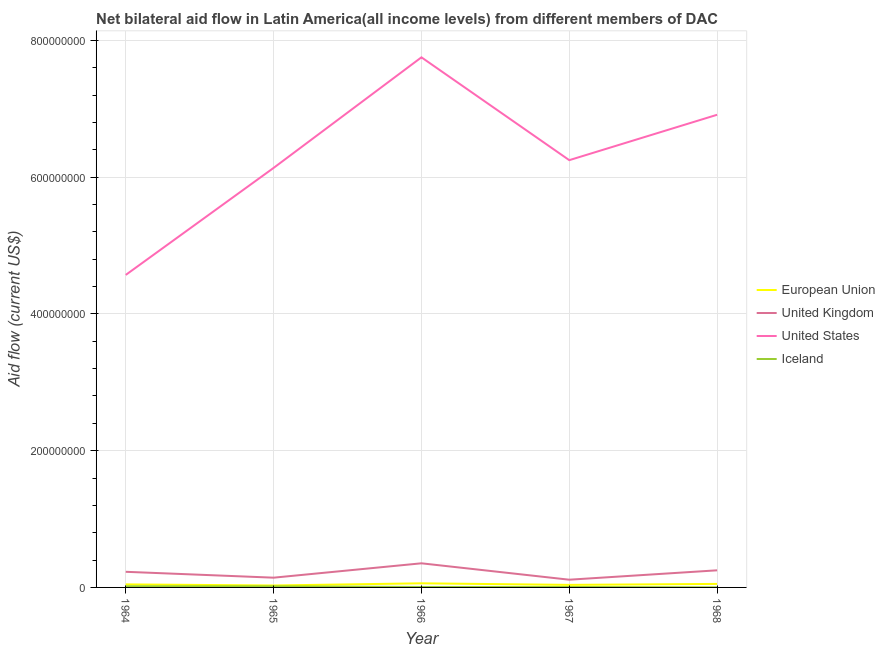How many different coloured lines are there?
Your response must be concise. 4. Is the number of lines equal to the number of legend labels?
Make the answer very short. Yes. What is the amount of aid given by us in 1968?
Offer a terse response. 6.91e+08. Across all years, what is the maximum amount of aid given by iceland?
Provide a short and direct response. 1.67e+06. Across all years, what is the minimum amount of aid given by iceland?
Make the answer very short. 1.50e+05. In which year was the amount of aid given by eu maximum?
Provide a short and direct response. 1966. In which year was the amount of aid given by iceland minimum?
Your answer should be very brief. 1968. What is the total amount of aid given by iceland in the graph?
Make the answer very short. 4.69e+06. What is the difference between the amount of aid given by uk in 1964 and that in 1966?
Keep it short and to the point. -1.24e+07. What is the difference between the amount of aid given by us in 1966 and the amount of aid given by eu in 1968?
Your answer should be very brief. 7.70e+08. What is the average amount of aid given by iceland per year?
Make the answer very short. 9.38e+05. In the year 1965, what is the difference between the amount of aid given by us and amount of aid given by eu?
Provide a short and direct response. 6.11e+08. What is the ratio of the amount of aid given by eu in 1966 to that in 1968?
Provide a short and direct response. 1.17. What is the difference between the highest and the second highest amount of aid given by eu?
Keep it short and to the point. 8.60e+05. What is the difference between the highest and the lowest amount of aid given by us?
Give a very brief answer. 3.18e+08. Is the sum of the amount of aid given by us in 1964 and 1967 greater than the maximum amount of aid given by eu across all years?
Your answer should be very brief. Yes. Is it the case that in every year, the sum of the amount of aid given by eu and amount of aid given by iceland is greater than the sum of amount of aid given by uk and amount of aid given by us?
Make the answer very short. No. Is it the case that in every year, the sum of the amount of aid given by eu and amount of aid given by uk is greater than the amount of aid given by us?
Ensure brevity in your answer.  No. Is the amount of aid given by eu strictly greater than the amount of aid given by iceland over the years?
Offer a very short reply. Yes. Is the amount of aid given by uk strictly less than the amount of aid given by us over the years?
Your answer should be compact. Yes. How many years are there in the graph?
Keep it short and to the point. 5. What is the difference between two consecutive major ticks on the Y-axis?
Provide a short and direct response. 2.00e+08. Are the values on the major ticks of Y-axis written in scientific E-notation?
Your answer should be very brief. No. Does the graph contain any zero values?
Offer a very short reply. No. How many legend labels are there?
Keep it short and to the point. 4. How are the legend labels stacked?
Provide a short and direct response. Vertical. What is the title of the graph?
Make the answer very short. Net bilateral aid flow in Latin America(all income levels) from different members of DAC. What is the label or title of the Y-axis?
Your answer should be compact. Aid flow (current US$). What is the Aid flow (current US$) of European Union in 1964?
Your response must be concise. 4.45e+06. What is the Aid flow (current US$) in United Kingdom in 1964?
Keep it short and to the point. 2.29e+07. What is the Aid flow (current US$) of United States in 1964?
Make the answer very short. 4.57e+08. What is the Aid flow (current US$) in Iceland in 1964?
Make the answer very short. 1.67e+06. What is the Aid flow (current US$) of European Union in 1965?
Make the answer very short. 2.85e+06. What is the Aid flow (current US$) in United Kingdom in 1965?
Your answer should be compact. 1.43e+07. What is the Aid flow (current US$) in United States in 1965?
Your answer should be compact. 6.13e+08. What is the Aid flow (current US$) of Iceland in 1965?
Keep it short and to the point. 1.53e+06. What is the Aid flow (current US$) in European Union in 1966?
Provide a short and direct response. 6.01e+06. What is the Aid flow (current US$) of United Kingdom in 1966?
Offer a terse response. 3.53e+07. What is the Aid flow (current US$) in United States in 1966?
Your answer should be very brief. 7.75e+08. What is the Aid flow (current US$) in Iceland in 1966?
Give a very brief answer. 6.80e+05. What is the Aid flow (current US$) of European Union in 1967?
Give a very brief answer. 3.73e+06. What is the Aid flow (current US$) in United Kingdom in 1967?
Keep it short and to the point. 1.13e+07. What is the Aid flow (current US$) of United States in 1967?
Your answer should be very brief. 6.25e+08. What is the Aid flow (current US$) in European Union in 1968?
Provide a succinct answer. 5.15e+06. What is the Aid flow (current US$) of United Kingdom in 1968?
Provide a short and direct response. 2.50e+07. What is the Aid flow (current US$) of United States in 1968?
Offer a very short reply. 6.91e+08. Across all years, what is the maximum Aid flow (current US$) of European Union?
Ensure brevity in your answer.  6.01e+06. Across all years, what is the maximum Aid flow (current US$) in United Kingdom?
Offer a terse response. 3.53e+07. Across all years, what is the maximum Aid flow (current US$) in United States?
Your response must be concise. 7.75e+08. Across all years, what is the maximum Aid flow (current US$) of Iceland?
Your response must be concise. 1.67e+06. Across all years, what is the minimum Aid flow (current US$) in European Union?
Provide a succinct answer. 2.85e+06. Across all years, what is the minimum Aid flow (current US$) of United Kingdom?
Your answer should be compact. 1.13e+07. Across all years, what is the minimum Aid flow (current US$) of United States?
Your answer should be compact. 4.57e+08. What is the total Aid flow (current US$) of European Union in the graph?
Give a very brief answer. 2.22e+07. What is the total Aid flow (current US$) of United Kingdom in the graph?
Your answer should be very brief. 1.09e+08. What is the total Aid flow (current US$) of United States in the graph?
Your response must be concise. 3.16e+09. What is the total Aid flow (current US$) in Iceland in the graph?
Your answer should be compact. 4.69e+06. What is the difference between the Aid flow (current US$) of European Union in 1964 and that in 1965?
Your response must be concise. 1.60e+06. What is the difference between the Aid flow (current US$) in United Kingdom in 1964 and that in 1965?
Your response must be concise. 8.60e+06. What is the difference between the Aid flow (current US$) in United States in 1964 and that in 1965?
Provide a succinct answer. -1.56e+08. What is the difference between the Aid flow (current US$) of Iceland in 1964 and that in 1965?
Offer a very short reply. 1.40e+05. What is the difference between the Aid flow (current US$) of European Union in 1964 and that in 1966?
Provide a succinct answer. -1.56e+06. What is the difference between the Aid flow (current US$) of United Kingdom in 1964 and that in 1966?
Keep it short and to the point. -1.24e+07. What is the difference between the Aid flow (current US$) in United States in 1964 and that in 1966?
Make the answer very short. -3.18e+08. What is the difference between the Aid flow (current US$) in Iceland in 1964 and that in 1966?
Keep it short and to the point. 9.90e+05. What is the difference between the Aid flow (current US$) of European Union in 1964 and that in 1967?
Give a very brief answer. 7.20e+05. What is the difference between the Aid flow (current US$) of United Kingdom in 1964 and that in 1967?
Your response must be concise. 1.16e+07. What is the difference between the Aid flow (current US$) of United States in 1964 and that in 1967?
Your answer should be very brief. -1.68e+08. What is the difference between the Aid flow (current US$) in Iceland in 1964 and that in 1967?
Offer a terse response. 1.01e+06. What is the difference between the Aid flow (current US$) of European Union in 1964 and that in 1968?
Keep it short and to the point. -7.00e+05. What is the difference between the Aid flow (current US$) in United Kingdom in 1964 and that in 1968?
Provide a succinct answer. -2.17e+06. What is the difference between the Aid flow (current US$) in United States in 1964 and that in 1968?
Offer a terse response. -2.34e+08. What is the difference between the Aid flow (current US$) of Iceland in 1964 and that in 1968?
Ensure brevity in your answer.  1.52e+06. What is the difference between the Aid flow (current US$) in European Union in 1965 and that in 1966?
Your answer should be compact. -3.16e+06. What is the difference between the Aid flow (current US$) of United Kingdom in 1965 and that in 1966?
Provide a succinct answer. -2.10e+07. What is the difference between the Aid flow (current US$) of United States in 1965 and that in 1966?
Your answer should be very brief. -1.62e+08. What is the difference between the Aid flow (current US$) of Iceland in 1965 and that in 1966?
Provide a short and direct response. 8.50e+05. What is the difference between the Aid flow (current US$) of European Union in 1965 and that in 1967?
Offer a terse response. -8.80e+05. What is the difference between the Aid flow (current US$) of United Kingdom in 1965 and that in 1967?
Your answer should be compact. 2.97e+06. What is the difference between the Aid flow (current US$) in United States in 1965 and that in 1967?
Offer a terse response. -1.14e+07. What is the difference between the Aid flow (current US$) in Iceland in 1965 and that in 1967?
Ensure brevity in your answer.  8.70e+05. What is the difference between the Aid flow (current US$) of European Union in 1965 and that in 1968?
Your answer should be very brief. -2.30e+06. What is the difference between the Aid flow (current US$) in United Kingdom in 1965 and that in 1968?
Offer a terse response. -1.08e+07. What is the difference between the Aid flow (current US$) in United States in 1965 and that in 1968?
Keep it short and to the point. -7.77e+07. What is the difference between the Aid flow (current US$) of Iceland in 1965 and that in 1968?
Make the answer very short. 1.38e+06. What is the difference between the Aid flow (current US$) of European Union in 1966 and that in 1967?
Keep it short and to the point. 2.28e+06. What is the difference between the Aid flow (current US$) of United Kingdom in 1966 and that in 1967?
Give a very brief answer. 2.40e+07. What is the difference between the Aid flow (current US$) in United States in 1966 and that in 1967?
Provide a succinct answer. 1.50e+08. What is the difference between the Aid flow (current US$) in Iceland in 1966 and that in 1967?
Your answer should be very brief. 2.00e+04. What is the difference between the Aid flow (current US$) of European Union in 1966 and that in 1968?
Provide a short and direct response. 8.60e+05. What is the difference between the Aid flow (current US$) in United Kingdom in 1966 and that in 1968?
Ensure brevity in your answer.  1.02e+07. What is the difference between the Aid flow (current US$) in United States in 1966 and that in 1968?
Provide a short and direct response. 8.40e+07. What is the difference between the Aid flow (current US$) of Iceland in 1966 and that in 1968?
Your answer should be very brief. 5.30e+05. What is the difference between the Aid flow (current US$) in European Union in 1967 and that in 1968?
Your response must be concise. -1.42e+06. What is the difference between the Aid flow (current US$) in United Kingdom in 1967 and that in 1968?
Your answer should be compact. -1.37e+07. What is the difference between the Aid flow (current US$) in United States in 1967 and that in 1968?
Offer a terse response. -6.64e+07. What is the difference between the Aid flow (current US$) of Iceland in 1967 and that in 1968?
Provide a short and direct response. 5.10e+05. What is the difference between the Aid flow (current US$) of European Union in 1964 and the Aid flow (current US$) of United Kingdom in 1965?
Keep it short and to the point. -9.81e+06. What is the difference between the Aid flow (current US$) in European Union in 1964 and the Aid flow (current US$) in United States in 1965?
Your answer should be compact. -6.09e+08. What is the difference between the Aid flow (current US$) of European Union in 1964 and the Aid flow (current US$) of Iceland in 1965?
Your answer should be very brief. 2.92e+06. What is the difference between the Aid flow (current US$) in United Kingdom in 1964 and the Aid flow (current US$) in United States in 1965?
Keep it short and to the point. -5.91e+08. What is the difference between the Aid flow (current US$) of United Kingdom in 1964 and the Aid flow (current US$) of Iceland in 1965?
Give a very brief answer. 2.13e+07. What is the difference between the Aid flow (current US$) in United States in 1964 and the Aid flow (current US$) in Iceland in 1965?
Provide a short and direct response. 4.55e+08. What is the difference between the Aid flow (current US$) of European Union in 1964 and the Aid flow (current US$) of United Kingdom in 1966?
Keep it short and to the point. -3.08e+07. What is the difference between the Aid flow (current US$) of European Union in 1964 and the Aid flow (current US$) of United States in 1966?
Provide a short and direct response. -7.71e+08. What is the difference between the Aid flow (current US$) of European Union in 1964 and the Aid flow (current US$) of Iceland in 1966?
Give a very brief answer. 3.77e+06. What is the difference between the Aid flow (current US$) in United Kingdom in 1964 and the Aid flow (current US$) in United States in 1966?
Keep it short and to the point. -7.52e+08. What is the difference between the Aid flow (current US$) in United Kingdom in 1964 and the Aid flow (current US$) in Iceland in 1966?
Your answer should be very brief. 2.22e+07. What is the difference between the Aid flow (current US$) of United States in 1964 and the Aid flow (current US$) of Iceland in 1966?
Provide a short and direct response. 4.56e+08. What is the difference between the Aid flow (current US$) in European Union in 1964 and the Aid flow (current US$) in United Kingdom in 1967?
Keep it short and to the point. -6.84e+06. What is the difference between the Aid flow (current US$) in European Union in 1964 and the Aid flow (current US$) in United States in 1967?
Provide a succinct answer. -6.20e+08. What is the difference between the Aid flow (current US$) in European Union in 1964 and the Aid flow (current US$) in Iceland in 1967?
Keep it short and to the point. 3.79e+06. What is the difference between the Aid flow (current US$) in United Kingdom in 1964 and the Aid flow (current US$) in United States in 1967?
Offer a very short reply. -6.02e+08. What is the difference between the Aid flow (current US$) of United Kingdom in 1964 and the Aid flow (current US$) of Iceland in 1967?
Your response must be concise. 2.22e+07. What is the difference between the Aid flow (current US$) in United States in 1964 and the Aid flow (current US$) in Iceland in 1967?
Provide a succinct answer. 4.56e+08. What is the difference between the Aid flow (current US$) in European Union in 1964 and the Aid flow (current US$) in United Kingdom in 1968?
Ensure brevity in your answer.  -2.06e+07. What is the difference between the Aid flow (current US$) in European Union in 1964 and the Aid flow (current US$) in United States in 1968?
Your answer should be compact. -6.87e+08. What is the difference between the Aid flow (current US$) of European Union in 1964 and the Aid flow (current US$) of Iceland in 1968?
Give a very brief answer. 4.30e+06. What is the difference between the Aid flow (current US$) of United Kingdom in 1964 and the Aid flow (current US$) of United States in 1968?
Offer a terse response. -6.68e+08. What is the difference between the Aid flow (current US$) of United Kingdom in 1964 and the Aid flow (current US$) of Iceland in 1968?
Ensure brevity in your answer.  2.27e+07. What is the difference between the Aid flow (current US$) in United States in 1964 and the Aid flow (current US$) in Iceland in 1968?
Your answer should be compact. 4.57e+08. What is the difference between the Aid flow (current US$) of European Union in 1965 and the Aid flow (current US$) of United Kingdom in 1966?
Keep it short and to the point. -3.24e+07. What is the difference between the Aid flow (current US$) of European Union in 1965 and the Aid flow (current US$) of United States in 1966?
Offer a very short reply. -7.72e+08. What is the difference between the Aid flow (current US$) in European Union in 1965 and the Aid flow (current US$) in Iceland in 1966?
Provide a succinct answer. 2.17e+06. What is the difference between the Aid flow (current US$) in United Kingdom in 1965 and the Aid flow (current US$) in United States in 1966?
Provide a short and direct response. -7.61e+08. What is the difference between the Aid flow (current US$) of United Kingdom in 1965 and the Aid flow (current US$) of Iceland in 1966?
Give a very brief answer. 1.36e+07. What is the difference between the Aid flow (current US$) of United States in 1965 and the Aid flow (current US$) of Iceland in 1966?
Your answer should be compact. 6.13e+08. What is the difference between the Aid flow (current US$) of European Union in 1965 and the Aid flow (current US$) of United Kingdom in 1967?
Make the answer very short. -8.44e+06. What is the difference between the Aid flow (current US$) in European Union in 1965 and the Aid flow (current US$) in United States in 1967?
Your response must be concise. -6.22e+08. What is the difference between the Aid flow (current US$) in European Union in 1965 and the Aid flow (current US$) in Iceland in 1967?
Your answer should be very brief. 2.19e+06. What is the difference between the Aid flow (current US$) in United Kingdom in 1965 and the Aid flow (current US$) in United States in 1967?
Provide a short and direct response. -6.11e+08. What is the difference between the Aid flow (current US$) of United Kingdom in 1965 and the Aid flow (current US$) of Iceland in 1967?
Your response must be concise. 1.36e+07. What is the difference between the Aid flow (current US$) of United States in 1965 and the Aid flow (current US$) of Iceland in 1967?
Your answer should be very brief. 6.13e+08. What is the difference between the Aid flow (current US$) in European Union in 1965 and the Aid flow (current US$) in United Kingdom in 1968?
Keep it short and to the point. -2.22e+07. What is the difference between the Aid flow (current US$) in European Union in 1965 and the Aid flow (current US$) in United States in 1968?
Offer a terse response. -6.88e+08. What is the difference between the Aid flow (current US$) in European Union in 1965 and the Aid flow (current US$) in Iceland in 1968?
Your answer should be very brief. 2.70e+06. What is the difference between the Aid flow (current US$) in United Kingdom in 1965 and the Aid flow (current US$) in United States in 1968?
Your answer should be very brief. -6.77e+08. What is the difference between the Aid flow (current US$) of United Kingdom in 1965 and the Aid flow (current US$) of Iceland in 1968?
Make the answer very short. 1.41e+07. What is the difference between the Aid flow (current US$) of United States in 1965 and the Aid flow (current US$) of Iceland in 1968?
Your answer should be very brief. 6.13e+08. What is the difference between the Aid flow (current US$) in European Union in 1966 and the Aid flow (current US$) in United Kingdom in 1967?
Your answer should be compact. -5.28e+06. What is the difference between the Aid flow (current US$) in European Union in 1966 and the Aid flow (current US$) in United States in 1967?
Keep it short and to the point. -6.19e+08. What is the difference between the Aid flow (current US$) in European Union in 1966 and the Aid flow (current US$) in Iceland in 1967?
Provide a short and direct response. 5.35e+06. What is the difference between the Aid flow (current US$) of United Kingdom in 1966 and the Aid flow (current US$) of United States in 1967?
Offer a terse response. -5.90e+08. What is the difference between the Aid flow (current US$) of United Kingdom in 1966 and the Aid flow (current US$) of Iceland in 1967?
Make the answer very short. 3.46e+07. What is the difference between the Aid flow (current US$) in United States in 1966 and the Aid flow (current US$) in Iceland in 1967?
Keep it short and to the point. 7.75e+08. What is the difference between the Aid flow (current US$) in European Union in 1966 and the Aid flow (current US$) in United Kingdom in 1968?
Offer a very short reply. -1.90e+07. What is the difference between the Aid flow (current US$) of European Union in 1966 and the Aid flow (current US$) of United States in 1968?
Your response must be concise. -6.85e+08. What is the difference between the Aid flow (current US$) in European Union in 1966 and the Aid flow (current US$) in Iceland in 1968?
Your response must be concise. 5.86e+06. What is the difference between the Aid flow (current US$) of United Kingdom in 1966 and the Aid flow (current US$) of United States in 1968?
Offer a very short reply. -6.56e+08. What is the difference between the Aid flow (current US$) in United Kingdom in 1966 and the Aid flow (current US$) in Iceland in 1968?
Make the answer very short. 3.51e+07. What is the difference between the Aid flow (current US$) of United States in 1966 and the Aid flow (current US$) of Iceland in 1968?
Give a very brief answer. 7.75e+08. What is the difference between the Aid flow (current US$) of European Union in 1967 and the Aid flow (current US$) of United Kingdom in 1968?
Ensure brevity in your answer.  -2.13e+07. What is the difference between the Aid flow (current US$) of European Union in 1967 and the Aid flow (current US$) of United States in 1968?
Your answer should be compact. -6.87e+08. What is the difference between the Aid flow (current US$) in European Union in 1967 and the Aid flow (current US$) in Iceland in 1968?
Your answer should be compact. 3.58e+06. What is the difference between the Aid flow (current US$) of United Kingdom in 1967 and the Aid flow (current US$) of United States in 1968?
Provide a succinct answer. -6.80e+08. What is the difference between the Aid flow (current US$) in United Kingdom in 1967 and the Aid flow (current US$) in Iceland in 1968?
Offer a very short reply. 1.11e+07. What is the difference between the Aid flow (current US$) in United States in 1967 and the Aid flow (current US$) in Iceland in 1968?
Offer a terse response. 6.25e+08. What is the average Aid flow (current US$) in European Union per year?
Make the answer very short. 4.44e+06. What is the average Aid flow (current US$) in United Kingdom per year?
Keep it short and to the point. 2.17e+07. What is the average Aid flow (current US$) in United States per year?
Your response must be concise. 6.32e+08. What is the average Aid flow (current US$) of Iceland per year?
Make the answer very short. 9.38e+05. In the year 1964, what is the difference between the Aid flow (current US$) in European Union and Aid flow (current US$) in United Kingdom?
Your response must be concise. -1.84e+07. In the year 1964, what is the difference between the Aid flow (current US$) in European Union and Aid flow (current US$) in United States?
Your answer should be compact. -4.53e+08. In the year 1964, what is the difference between the Aid flow (current US$) in European Union and Aid flow (current US$) in Iceland?
Offer a very short reply. 2.78e+06. In the year 1964, what is the difference between the Aid flow (current US$) in United Kingdom and Aid flow (current US$) in United States?
Make the answer very short. -4.34e+08. In the year 1964, what is the difference between the Aid flow (current US$) of United Kingdom and Aid flow (current US$) of Iceland?
Keep it short and to the point. 2.12e+07. In the year 1964, what is the difference between the Aid flow (current US$) in United States and Aid flow (current US$) in Iceland?
Provide a short and direct response. 4.55e+08. In the year 1965, what is the difference between the Aid flow (current US$) of European Union and Aid flow (current US$) of United Kingdom?
Offer a terse response. -1.14e+07. In the year 1965, what is the difference between the Aid flow (current US$) of European Union and Aid flow (current US$) of United States?
Keep it short and to the point. -6.11e+08. In the year 1965, what is the difference between the Aid flow (current US$) of European Union and Aid flow (current US$) of Iceland?
Ensure brevity in your answer.  1.32e+06. In the year 1965, what is the difference between the Aid flow (current US$) of United Kingdom and Aid flow (current US$) of United States?
Your answer should be compact. -5.99e+08. In the year 1965, what is the difference between the Aid flow (current US$) in United Kingdom and Aid flow (current US$) in Iceland?
Ensure brevity in your answer.  1.27e+07. In the year 1965, what is the difference between the Aid flow (current US$) of United States and Aid flow (current US$) of Iceland?
Offer a terse response. 6.12e+08. In the year 1966, what is the difference between the Aid flow (current US$) of European Union and Aid flow (current US$) of United Kingdom?
Provide a succinct answer. -2.93e+07. In the year 1966, what is the difference between the Aid flow (current US$) of European Union and Aid flow (current US$) of United States?
Your answer should be very brief. -7.69e+08. In the year 1966, what is the difference between the Aid flow (current US$) in European Union and Aid flow (current US$) in Iceland?
Ensure brevity in your answer.  5.33e+06. In the year 1966, what is the difference between the Aid flow (current US$) of United Kingdom and Aid flow (current US$) of United States?
Make the answer very short. -7.40e+08. In the year 1966, what is the difference between the Aid flow (current US$) in United Kingdom and Aid flow (current US$) in Iceland?
Provide a succinct answer. 3.46e+07. In the year 1966, what is the difference between the Aid flow (current US$) of United States and Aid flow (current US$) of Iceland?
Your answer should be very brief. 7.75e+08. In the year 1967, what is the difference between the Aid flow (current US$) in European Union and Aid flow (current US$) in United Kingdom?
Your answer should be very brief. -7.56e+06. In the year 1967, what is the difference between the Aid flow (current US$) of European Union and Aid flow (current US$) of United States?
Offer a very short reply. -6.21e+08. In the year 1967, what is the difference between the Aid flow (current US$) of European Union and Aid flow (current US$) of Iceland?
Your answer should be very brief. 3.07e+06. In the year 1967, what is the difference between the Aid flow (current US$) in United Kingdom and Aid flow (current US$) in United States?
Your answer should be very brief. -6.14e+08. In the year 1967, what is the difference between the Aid flow (current US$) in United Kingdom and Aid flow (current US$) in Iceland?
Provide a short and direct response. 1.06e+07. In the year 1967, what is the difference between the Aid flow (current US$) of United States and Aid flow (current US$) of Iceland?
Make the answer very short. 6.24e+08. In the year 1968, what is the difference between the Aid flow (current US$) of European Union and Aid flow (current US$) of United Kingdom?
Your answer should be very brief. -1.99e+07. In the year 1968, what is the difference between the Aid flow (current US$) in European Union and Aid flow (current US$) in United States?
Give a very brief answer. -6.86e+08. In the year 1968, what is the difference between the Aid flow (current US$) in United Kingdom and Aid flow (current US$) in United States?
Make the answer very short. -6.66e+08. In the year 1968, what is the difference between the Aid flow (current US$) of United Kingdom and Aid flow (current US$) of Iceland?
Your answer should be very brief. 2.49e+07. In the year 1968, what is the difference between the Aid flow (current US$) in United States and Aid flow (current US$) in Iceland?
Your response must be concise. 6.91e+08. What is the ratio of the Aid flow (current US$) of European Union in 1964 to that in 1965?
Your answer should be very brief. 1.56. What is the ratio of the Aid flow (current US$) in United Kingdom in 1964 to that in 1965?
Make the answer very short. 1.6. What is the ratio of the Aid flow (current US$) in United States in 1964 to that in 1965?
Your answer should be compact. 0.74. What is the ratio of the Aid flow (current US$) of Iceland in 1964 to that in 1965?
Give a very brief answer. 1.09. What is the ratio of the Aid flow (current US$) of European Union in 1964 to that in 1966?
Your answer should be very brief. 0.74. What is the ratio of the Aid flow (current US$) of United Kingdom in 1964 to that in 1966?
Ensure brevity in your answer.  0.65. What is the ratio of the Aid flow (current US$) in United States in 1964 to that in 1966?
Your answer should be very brief. 0.59. What is the ratio of the Aid flow (current US$) in Iceland in 1964 to that in 1966?
Offer a very short reply. 2.46. What is the ratio of the Aid flow (current US$) in European Union in 1964 to that in 1967?
Ensure brevity in your answer.  1.19. What is the ratio of the Aid flow (current US$) of United Kingdom in 1964 to that in 1967?
Keep it short and to the point. 2.02. What is the ratio of the Aid flow (current US$) in United States in 1964 to that in 1967?
Provide a succinct answer. 0.73. What is the ratio of the Aid flow (current US$) of Iceland in 1964 to that in 1967?
Offer a very short reply. 2.53. What is the ratio of the Aid flow (current US$) of European Union in 1964 to that in 1968?
Ensure brevity in your answer.  0.86. What is the ratio of the Aid flow (current US$) of United Kingdom in 1964 to that in 1968?
Offer a very short reply. 0.91. What is the ratio of the Aid flow (current US$) of United States in 1964 to that in 1968?
Make the answer very short. 0.66. What is the ratio of the Aid flow (current US$) in Iceland in 1964 to that in 1968?
Your answer should be very brief. 11.13. What is the ratio of the Aid flow (current US$) of European Union in 1965 to that in 1966?
Ensure brevity in your answer.  0.47. What is the ratio of the Aid flow (current US$) in United Kingdom in 1965 to that in 1966?
Give a very brief answer. 0.4. What is the ratio of the Aid flow (current US$) of United States in 1965 to that in 1966?
Give a very brief answer. 0.79. What is the ratio of the Aid flow (current US$) of Iceland in 1965 to that in 1966?
Your answer should be very brief. 2.25. What is the ratio of the Aid flow (current US$) in European Union in 1965 to that in 1967?
Your answer should be very brief. 0.76. What is the ratio of the Aid flow (current US$) of United Kingdom in 1965 to that in 1967?
Offer a terse response. 1.26. What is the ratio of the Aid flow (current US$) of United States in 1965 to that in 1967?
Offer a very short reply. 0.98. What is the ratio of the Aid flow (current US$) in Iceland in 1965 to that in 1967?
Your response must be concise. 2.32. What is the ratio of the Aid flow (current US$) in European Union in 1965 to that in 1968?
Your response must be concise. 0.55. What is the ratio of the Aid flow (current US$) in United Kingdom in 1965 to that in 1968?
Give a very brief answer. 0.57. What is the ratio of the Aid flow (current US$) in United States in 1965 to that in 1968?
Your response must be concise. 0.89. What is the ratio of the Aid flow (current US$) of Iceland in 1965 to that in 1968?
Give a very brief answer. 10.2. What is the ratio of the Aid flow (current US$) of European Union in 1966 to that in 1967?
Your answer should be compact. 1.61. What is the ratio of the Aid flow (current US$) in United Kingdom in 1966 to that in 1967?
Provide a succinct answer. 3.12. What is the ratio of the Aid flow (current US$) in United States in 1966 to that in 1967?
Provide a short and direct response. 1.24. What is the ratio of the Aid flow (current US$) of Iceland in 1966 to that in 1967?
Your answer should be very brief. 1.03. What is the ratio of the Aid flow (current US$) in European Union in 1966 to that in 1968?
Your response must be concise. 1.17. What is the ratio of the Aid flow (current US$) in United Kingdom in 1966 to that in 1968?
Offer a very short reply. 1.41. What is the ratio of the Aid flow (current US$) in United States in 1966 to that in 1968?
Offer a very short reply. 1.12. What is the ratio of the Aid flow (current US$) of Iceland in 1966 to that in 1968?
Keep it short and to the point. 4.53. What is the ratio of the Aid flow (current US$) of European Union in 1967 to that in 1968?
Keep it short and to the point. 0.72. What is the ratio of the Aid flow (current US$) in United Kingdom in 1967 to that in 1968?
Make the answer very short. 0.45. What is the ratio of the Aid flow (current US$) of United States in 1967 to that in 1968?
Keep it short and to the point. 0.9. What is the difference between the highest and the second highest Aid flow (current US$) of European Union?
Your response must be concise. 8.60e+05. What is the difference between the highest and the second highest Aid flow (current US$) of United Kingdom?
Offer a terse response. 1.02e+07. What is the difference between the highest and the second highest Aid flow (current US$) of United States?
Your response must be concise. 8.40e+07. What is the difference between the highest and the second highest Aid flow (current US$) in Iceland?
Your response must be concise. 1.40e+05. What is the difference between the highest and the lowest Aid flow (current US$) of European Union?
Ensure brevity in your answer.  3.16e+06. What is the difference between the highest and the lowest Aid flow (current US$) in United Kingdom?
Keep it short and to the point. 2.40e+07. What is the difference between the highest and the lowest Aid flow (current US$) of United States?
Offer a terse response. 3.18e+08. What is the difference between the highest and the lowest Aid flow (current US$) in Iceland?
Your answer should be very brief. 1.52e+06. 